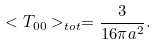Convert formula to latex. <formula><loc_0><loc_0><loc_500><loc_500>< T _ { 0 0 } > _ { t o t } = \frac { 3 } { 1 6 \pi a ^ { 2 } } .</formula> 